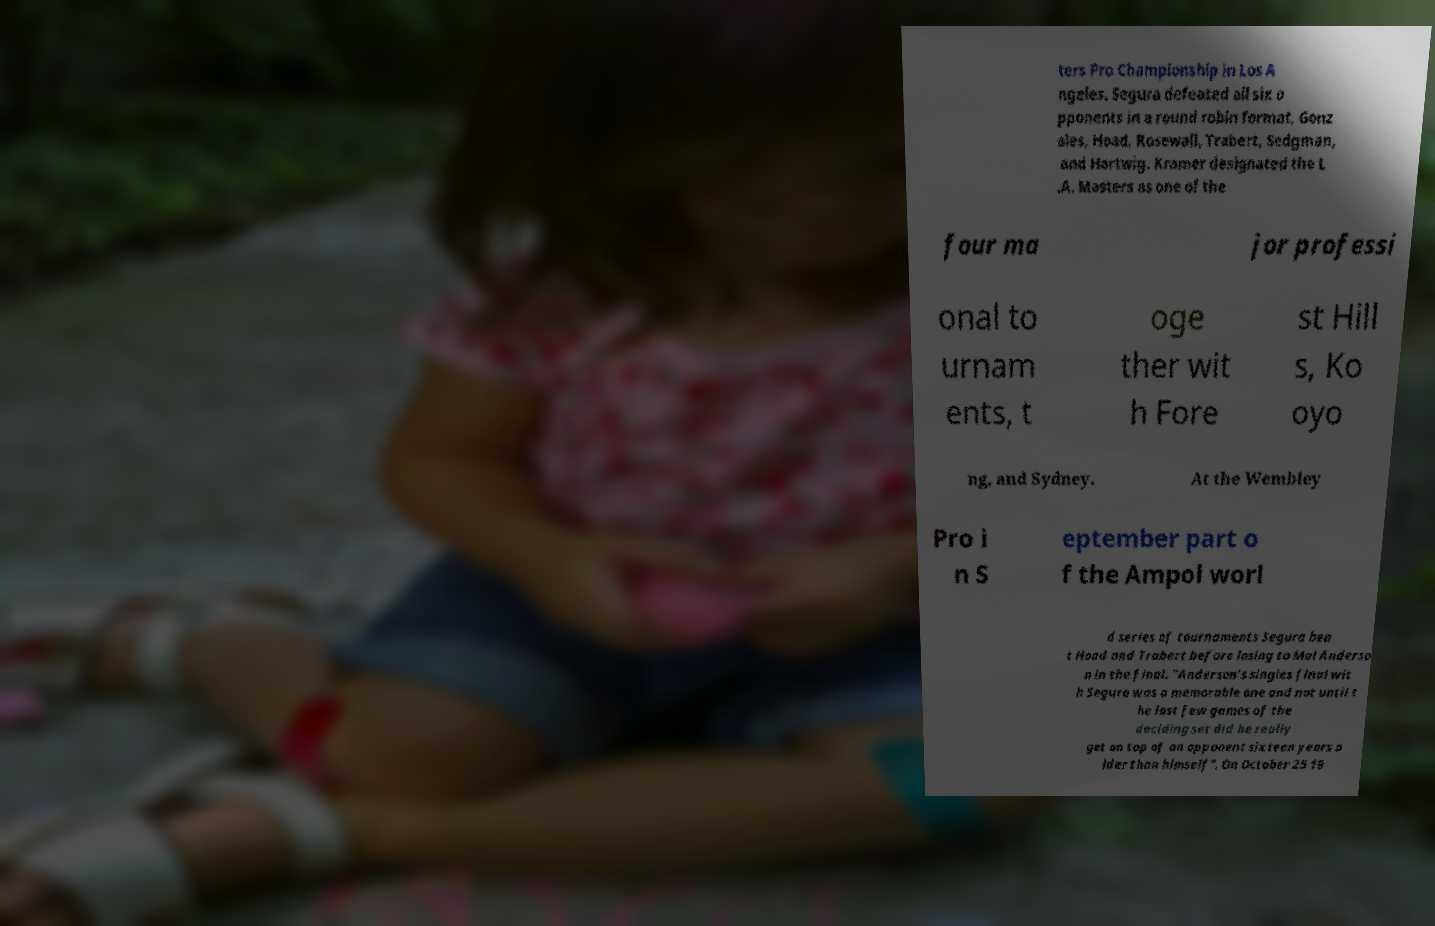Please read and relay the text visible in this image. What does it say? ters Pro Championship in Los A ngeles. Segura defeated all six o pponents in a round robin format, Gonz ales, Hoad, Rosewall, Trabert, Sedgman, and Hartwig. Kramer designated the L .A. Masters as one of the four ma jor professi onal to urnam ents, t oge ther wit h Fore st Hill s, Ko oyo ng, and Sydney. At the Wembley Pro i n S eptember part o f the Ampol worl d series of tournaments Segura bea t Hoad and Trabert before losing to Mal Anderso n in the final. "Anderson's singles final wit h Segura was a memorable one and not until t he last few games of the deciding set did he really get on top of an opponent sixteen years o lder than himself". On October 25 19 